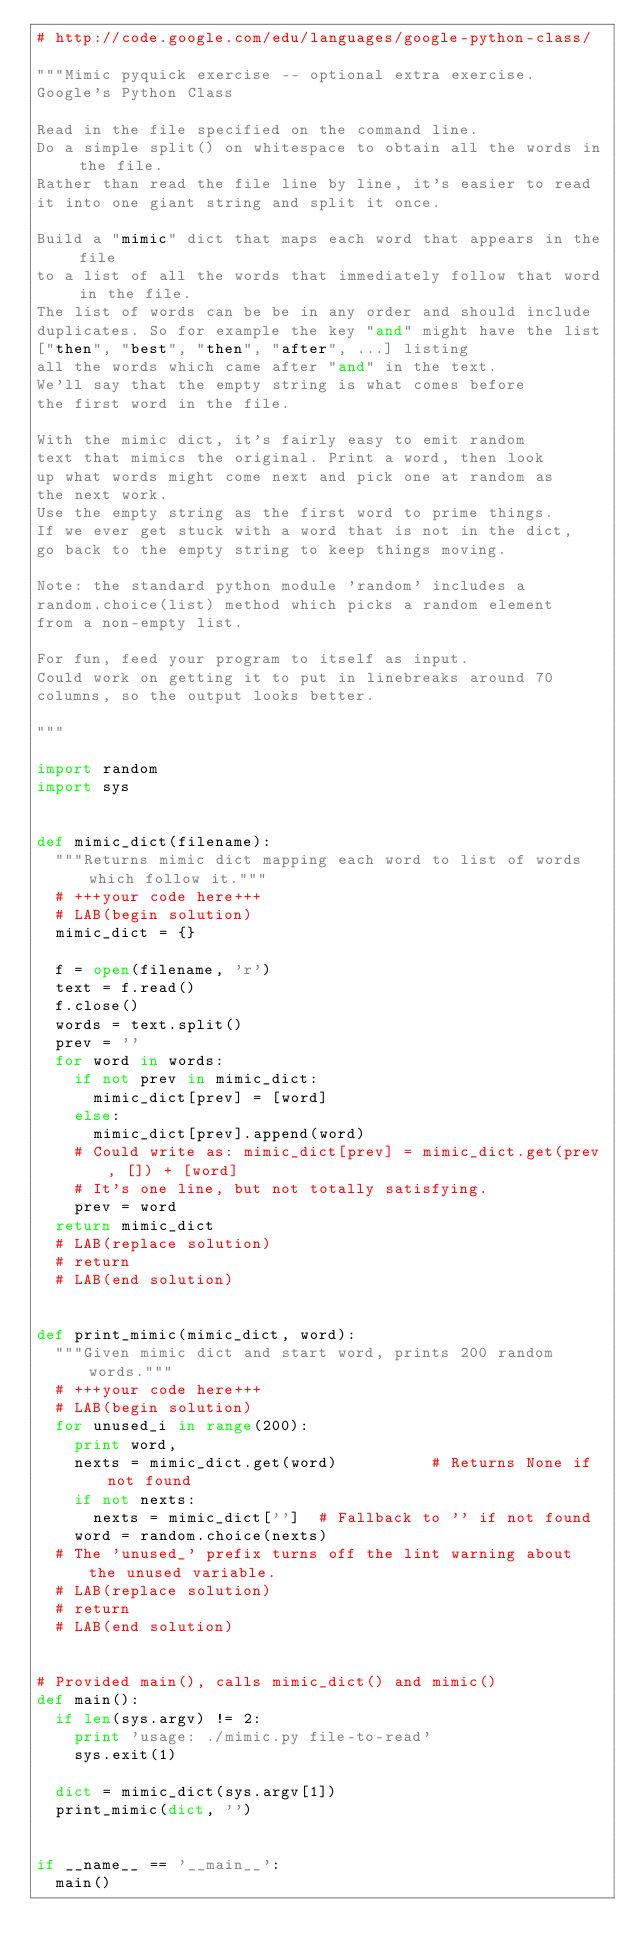Convert code to text. <code><loc_0><loc_0><loc_500><loc_500><_Python_># http://code.google.com/edu/languages/google-python-class/

"""Mimic pyquick exercise -- optional extra exercise.
Google's Python Class

Read in the file specified on the command line.
Do a simple split() on whitespace to obtain all the words in the file.
Rather than read the file line by line, it's easier to read
it into one giant string and split it once.

Build a "mimic" dict that maps each word that appears in the file
to a list of all the words that immediately follow that word in the file.
The list of words can be be in any order and should include
duplicates. So for example the key "and" might have the list
["then", "best", "then", "after", ...] listing
all the words which came after "and" in the text.
We'll say that the empty string is what comes before
the first word in the file.

With the mimic dict, it's fairly easy to emit random
text that mimics the original. Print a word, then look
up what words might come next and pick one at random as
the next work.
Use the empty string as the first word to prime things.
If we ever get stuck with a word that is not in the dict,
go back to the empty string to keep things moving.

Note: the standard python module 'random' includes a
random.choice(list) method which picks a random element
from a non-empty list.

For fun, feed your program to itself as input.
Could work on getting it to put in linebreaks around 70
columns, so the output looks better.

"""

import random
import sys


def mimic_dict(filename):
  """Returns mimic dict mapping each word to list of words which follow it."""
  # +++your code here+++
  # LAB(begin solution)
  mimic_dict = {}

  f = open(filename, 'r')
  text = f.read()
  f.close()
  words = text.split()
  prev = ''
  for word in words:
    if not prev in mimic_dict:
      mimic_dict[prev] = [word]
    else:
      mimic_dict[prev].append(word)
    # Could write as: mimic_dict[prev] = mimic_dict.get(prev, []) + [word]
    # It's one line, but not totally satisfying.
    prev = word
  return mimic_dict
  # LAB(replace solution)
  # return
  # LAB(end solution)


def print_mimic(mimic_dict, word):
  """Given mimic dict and start word, prints 200 random words."""
  # +++your code here+++
  # LAB(begin solution)
  for unused_i in range(200):
    print word,
    nexts = mimic_dict.get(word)          # Returns None if not found
    if not nexts:
      nexts = mimic_dict['']  # Fallback to '' if not found
    word = random.choice(nexts)
  # The 'unused_' prefix turns off the lint warning about the unused variable.
  # LAB(replace solution)
  # return
  # LAB(end solution)


# Provided main(), calls mimic_dict() and mimic()
def main():
  if len(sys.argv) != 2:
    print 'usage: ./mimic.py file-to-read'
    sys.exit(1)

  dict = mimic_dict(sys.argv[1])
  print_mimic(dict, '')


if __name__ == '__main__':
  main()
</code> 